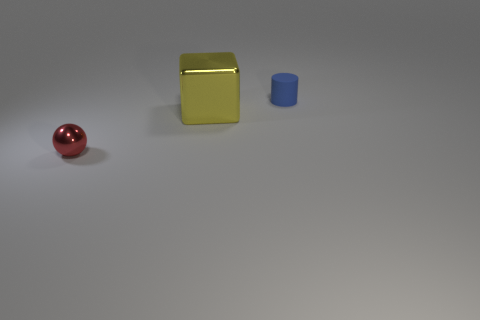Add 3 tiny cyan matte cylinders. How many objects exist? 6 Subtract all cylinders. How many objects are left? 2 Subtract all yellow metal objects. Subtract all small rubber things. How many objects are left? 1 Add 2 small red metal spheres. How many small red metal spheres are left? 3 Add 1 big yellow blocks. How many big yellow blocks exist? 2 Subtract 0 yellow spheres. How many objects are left? 3 